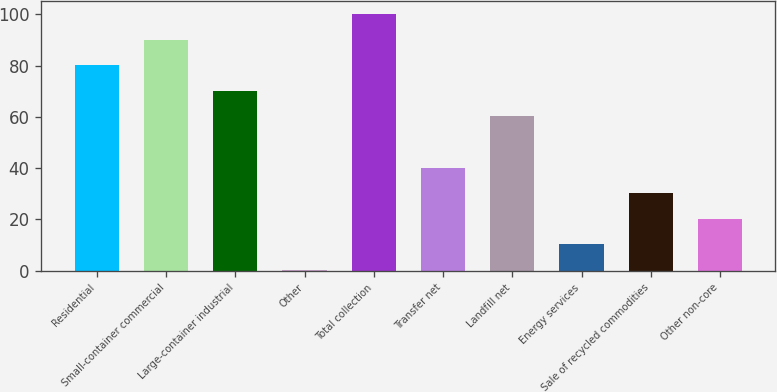<chart> <loc_0><loc_0><loc_500><loc_500><bar_chart><fcel>Residential<fcel>Small-container commercial<fcel>Large-container industrial<fcel>Other<fcel>Total collection<fcel>Transfer net<fcel>Landfill net<fcel>Energy services<fcel>Sale of recycled commodities<fcel>Other non-core<nl><fcel>80.08<fcel>90.04<fcel>70.12<fcel>0.4<fcel>100<fcel>40.24<fcel>60.16<fcel>10.36<fcel>30.28<fcel>20.32<nl></chart> 